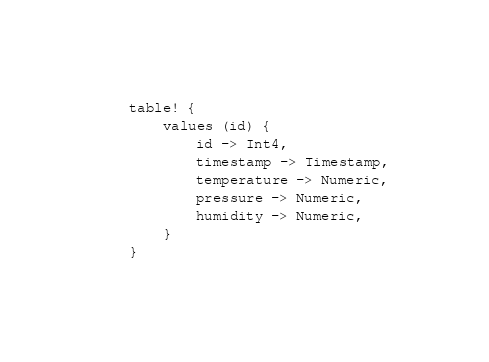Convert code to text. <code><loc_0><loc_0><loc_500><loc_500><_Rust_>table! {
    values (id) {
        id -> Int4,
        timestamp -> Timestamp,
        temperature -> Numeric,
        pressure -> Numeric,
        humidity -> Numeric,
    }
}
</code> 